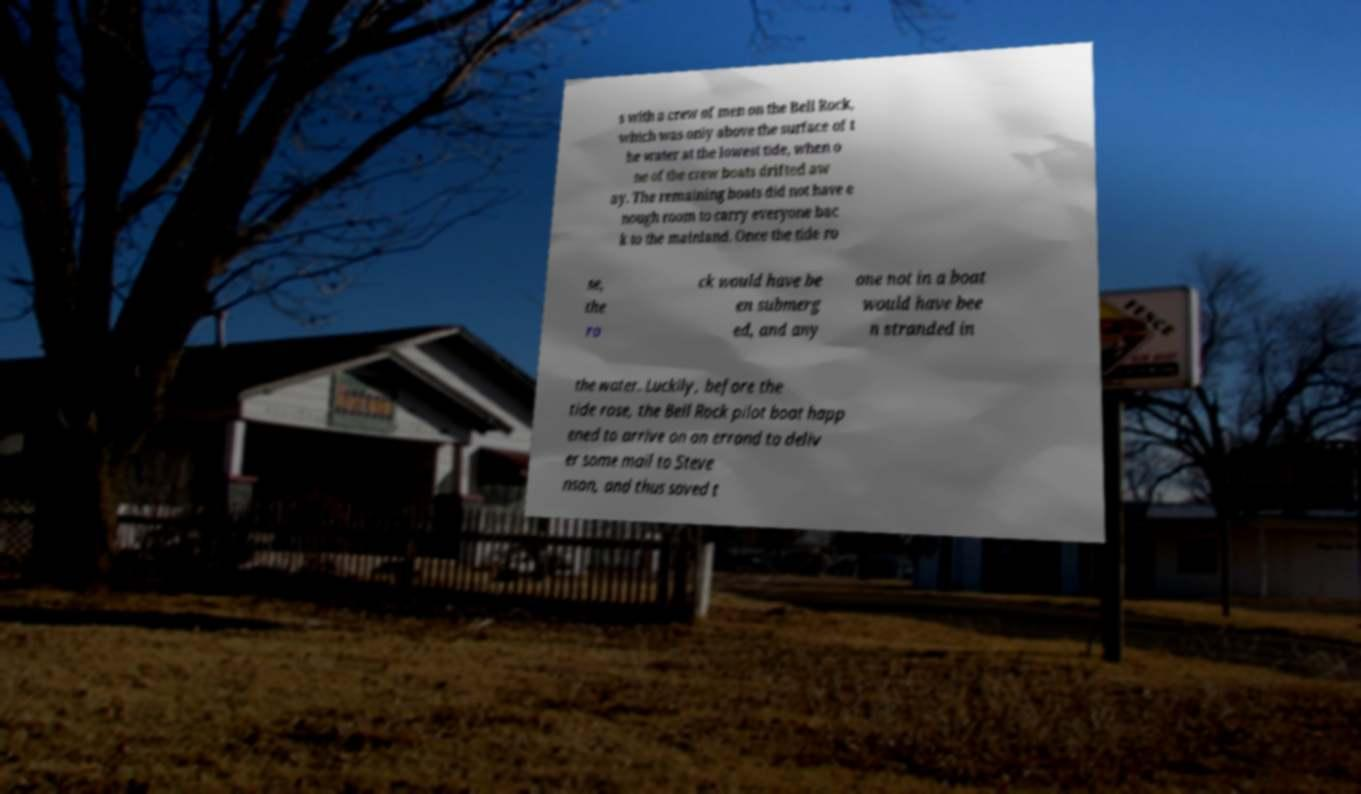Could you assist in decoding the text presented in this image and type it out clearly? s with a crew of men on the Bell Rock, which was only above the surface of t he water at the lowest tide, when o ne of the crew boats drifted aw ay. The remaining boats did not have e nough room to carry everyone bac k to the mainland. Once the tide ro se, the ro ck would have be en submerg ed, and any one not in a boat would have bee n stranded in the water. Luckily, before the tide rose, the Bell Rock pilot boat happ ened to arrive on an errand to deliv er some mail to Steve nson, and thus saved t 